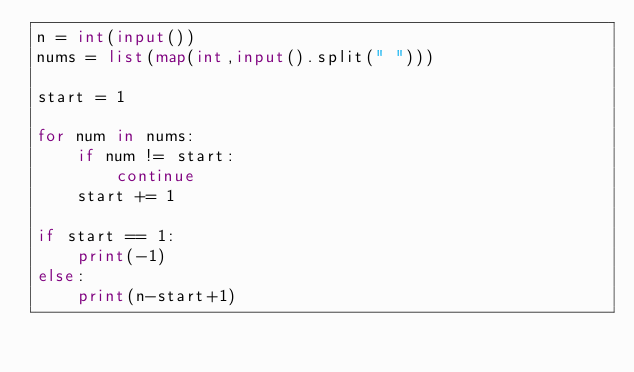<code> <loc_0><loc_0><loc_500><loc_500><_Python_>n = int(input())
nums = list(map(int,input().split(" ")))

start = 1

for num in nums:
    if num != start:
        continue
    start += 1

if start == 1:
    print(-1)
else:
    print(n-start+1)</code> 